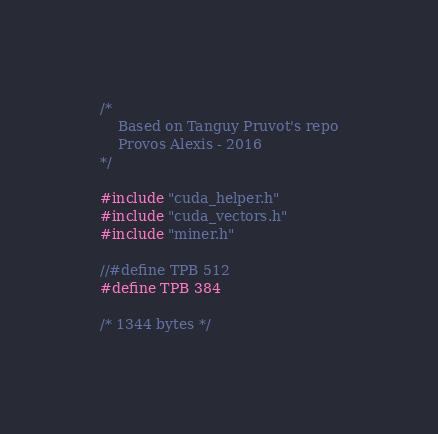Convert code to text. <code><loc_0><loc_0><loc_500><loc_500><_Cuda_>/*
	Based on Tanguy Pruvot's repo
	Provos Alexis - 2016
*/

#include "cuda_helper.h"
#include "cuda_vectors.h"
#include "miner.h"

//#define TPB 512
#define TPB 384

/* 1344 bytes */</code> 